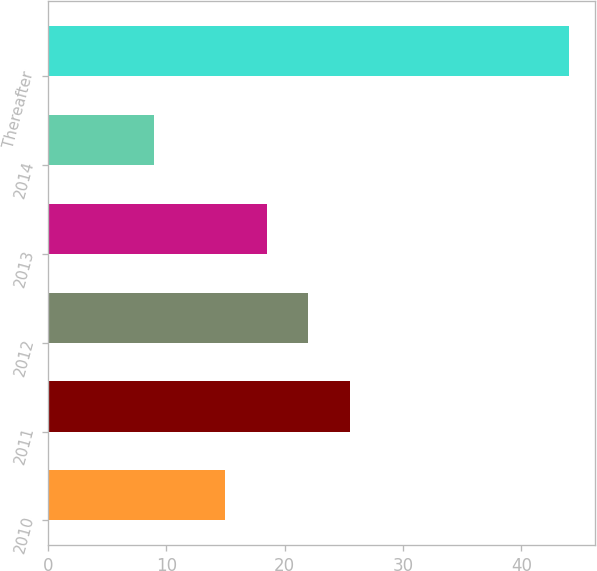Convert chart to OTSL. <chart><loc_0><loc_0><loc_500><loc_500><bar_chart><fcel>2010<fcel>2011<fcel>2012<fcel>2013<fcel>2014<fcel>Thereafter<nl><fcel>15<fcel>25.5<fcel>22<fcel>18.5<fcel>9<fcel>44<nl></chart> 